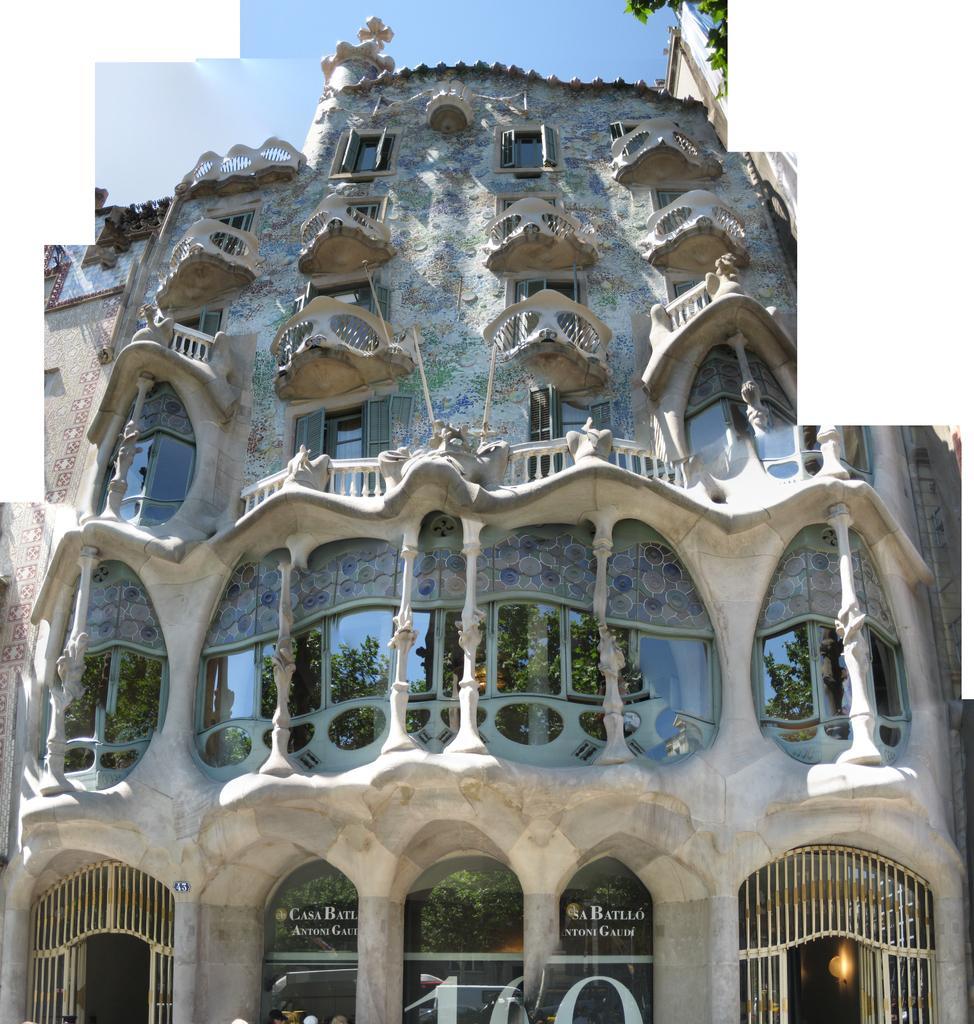Could you give a brief overview of what you see in this image? In this image, we can see a building. At the top of the image, we can see the sky. 